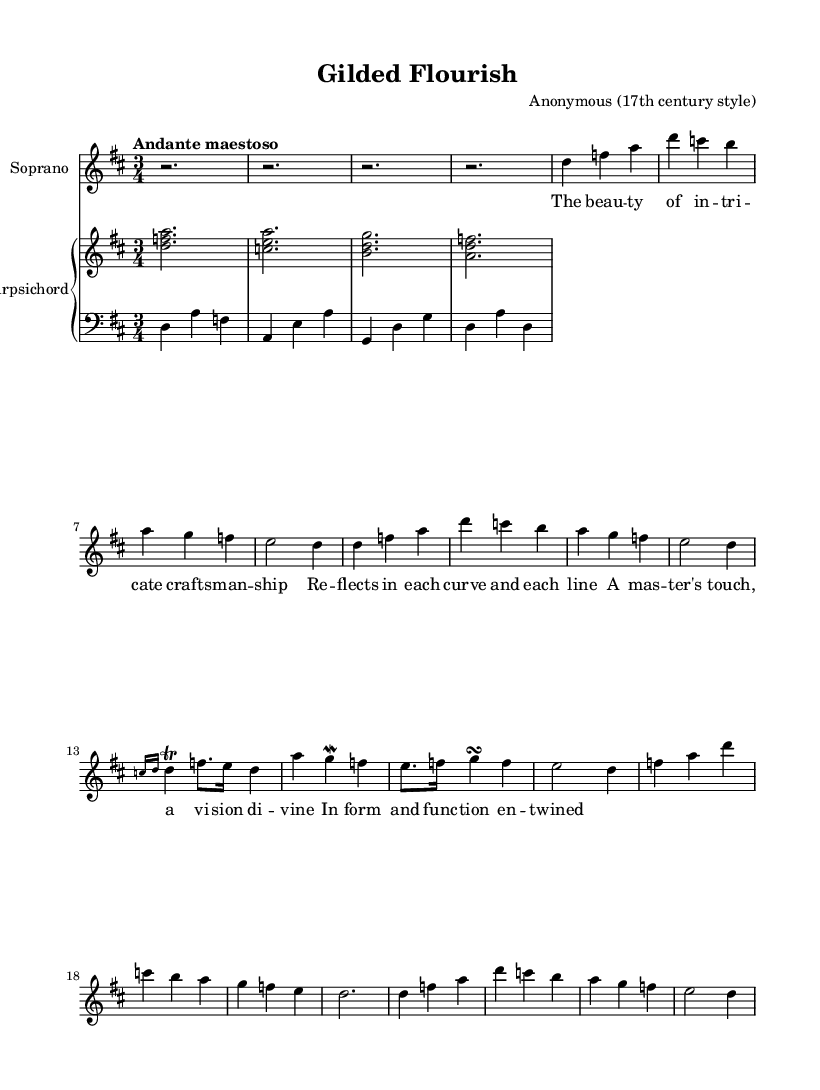What is the key signature of this piece? The key signature indicates that this music is in D major, which has two sharps (F# and C#).
Answer: D major What is the time signature of the piece? The time signature appears as 3/4, indicating three beats per measure with a quarter note receiving one beat.
Answer: 3/4 What tempo is indicated for the music? The tempo marking "Andante maestoso" suggests a moderately slow, majestic tempo, often associated with Baroque style music.
Answer: Andante maestoso How many verses are included in the lyrics? The lyrics contain two sections labeled as Verse A and Verse B, with Verse A appearing twice before reaching the coda.
Answer: Two What ornaments are present in the ornate refrain? In the ornate refrain, the markings indicate a trill on the note F, and there is a grace note leading to D.
Answer: Trill and grace note What structural element is commonly found in Baroque arias as reflected in this piece? The structure includes repeated sections, specifically the return to Verse A after Verse B, which is characteristic of Baroque operatic form.
Answer: Repetition How is the harpsichord's role characterized in this score? The harpsichord provides accompaniment and harmony, primarily featuring simple textures with contrasting upper and lower voices, typical of Baroque music's texture.
Answer: Accompaniment 